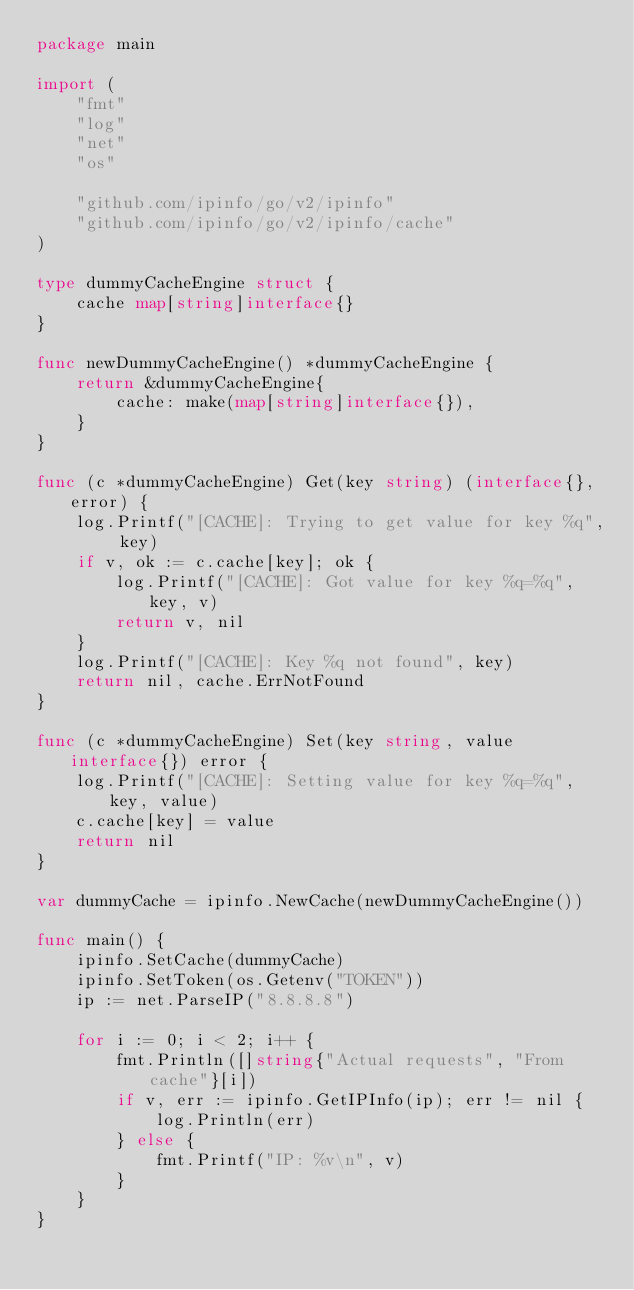<code> <loc_0><loc_0><loc_500><loc_500><_Go_>package main

import (
	"fmt"
	"log"
	"net"
	"os"

	"github.com/ipinfo/go/v2/ipinfo"
	"github.com/ipinfo/go/v2/ipinfo/cache"
)

type dummyCacheEngine struct {
	cache map[string]interface{}
}

func newDummyCacheEngine() *dummyCacheEngine {
	return &dummyCacheEngine{
		cache: make(map[string]interface{}),
	}
}

func (c *dummyCacheEngine) Get(key string) (interface{}, error) {
	log.Printf("[CACHE]: Trying to get value for key %q", key)
	if v, ok := c.cache[key]; ok {
		log.Printf("[CACHE]: Got value for key %q=%q", key, v)
		return v, nil
	}
	log.Printf("[CACHE]: Key %q not found", key)
	return nil, cache.ErrNotFound
}

func (c *dummyCacheEngine) Set(key string, value interface{}) error {
	log.Printf("[CACHE]: Setting value for key %q=%q", key, value)
	c.cache[key] = value
	return nil
}

var dummyCache = ipinfo.NewCache(newDummyCacheEngine())

func main() {
	ipinfo.SetCache(dummyCache)
	ipinfo.SetToken(os.Getenv("TOKEN"))
	ip := net.ParseIP("8.8.8.8")

	for i := 0; i < 2; i++ {
		fmt.Println([]string{"Actual requests", "From cache"}[i])
		if v, err := ipinfo.GetIPInfo(ip); err != nil {
			log.Println(err)
		} else {
			fmt.Printf("IP: %v\n", v)
		}
	}
}
</code> 